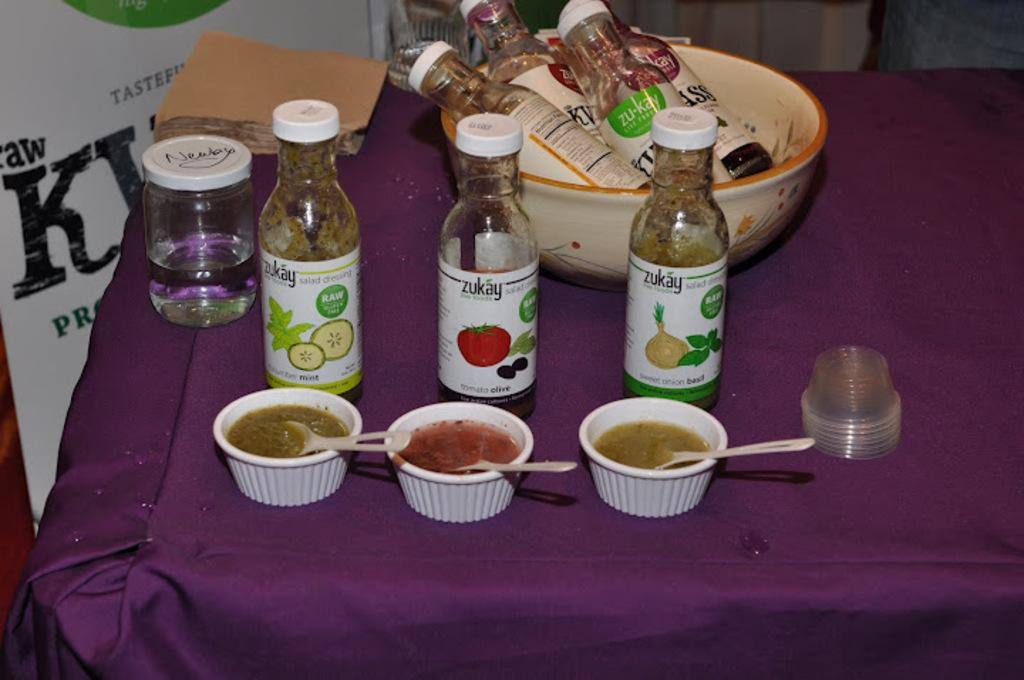What type of furniture is present in the image? There is a table in the image. What is covering the table? The table is covered with a tablecloth. What can be found on top of the table? There are different objects on the table. Is there any text visible in the image? Yes, there is a banner with text near the table. What type of engine is powering the root in the image? There is no engine or root present in the image. 